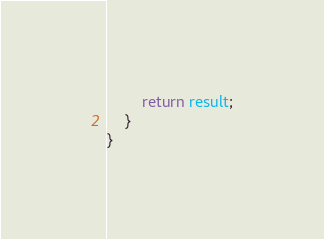Convert code to text. <code><loc_0><loc_0><loc_500><loc_500><_TypeScript_>        return result;
    }
}</code> 